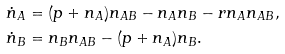<formula> <loc_0><loc_0><loc_500><loc_500>\dot { n } _ { A } & = ( p + n _ { A } ) n _ { A B } - n _ { A } n _ { B } - r n _ { A } n _ { A B } , \\ \dot { n } _ { B } & = n _ { B } n _ { A B } - ( p + n _ { A } ) n _ { B } .</formula> 